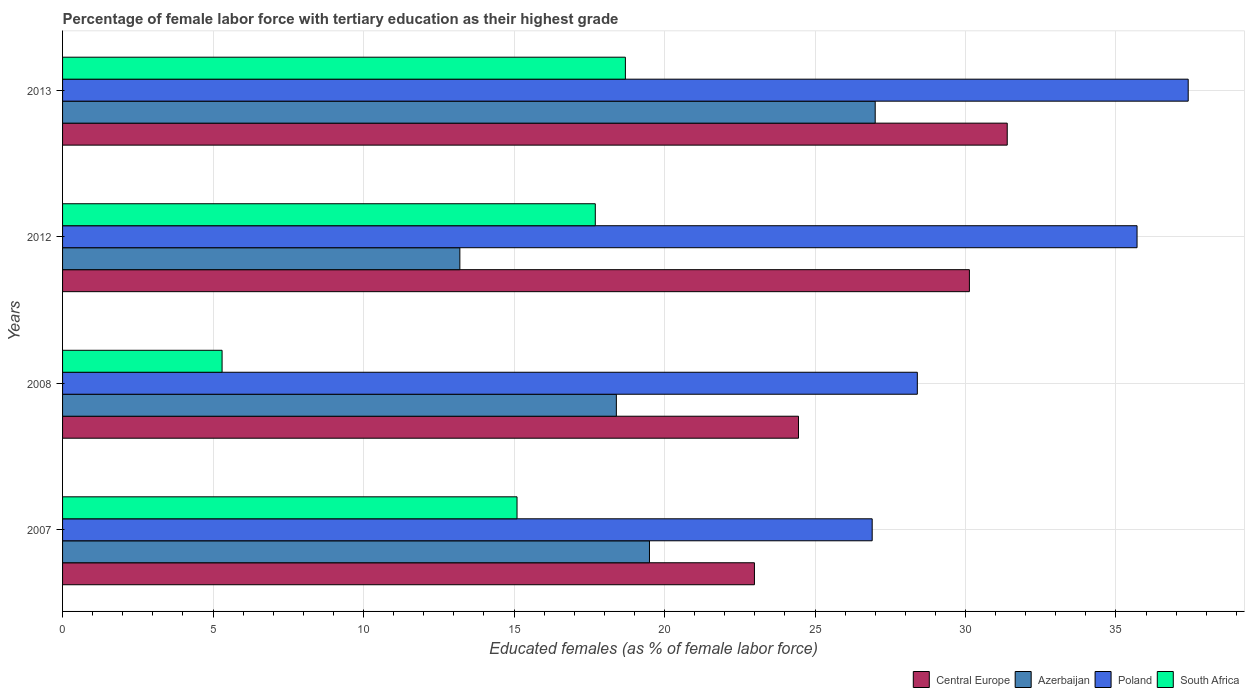How many different coloured bars are there?
Provide a succinct answer. 4. Are the number of bars per tick equal to the number of legend labels?
Provide a short and direct response. Yes. Are the number of bars on each tick of the Y-axis equal?
Offer a very short reply. Yes. How many bars are there on the 2nd tick from the top?
Provide a succinct answer. 4. What is the label of the 3rd group of bars from the top?
Keep it short and to the point. 2008. What is the percentage of female labor force with tertiary education in South Africa in 2008?
Provide a succinct answer. 5.3. Across all years, what is the maximum percentage of female labor force with tertiary education in South Africa?
Ensure brevity in your answer.  18.7. Across all years, what is the minimum percentage of female labor force with tertiary education in Poland?
Ensure brevity in your answer.  26.9. In which year was the percentage of female labor force with tertiary education in Central Europe minimum?
Provide a succinct answer. 2007. What is the total percentage of female labor force with tertiary education in Poland in the graph?
Keep it short and to the point. 128.4. What is the difference between the percentage of female labor force with tertiary education in South Africa in 2007 and that in 2008?
Offer a very short reply. 9.8. What is the difference between the percentage of female labor force with tertiary education in Azerbaijan in 2013 and the percentage of female labor force with tertiary education in Central Europe in 2007?
Provide a short and direct response. 4.01. What is the average percentage of female labor force with tertiary education in Azerbaijan per year?
Keep it short and to the point. 19.52. In the year 2007, what is the difference between the percentage of female labor force with tertiary education in South Africa and percentage of female labor force with tertiary education in Azerbaijan?
Your answer should be very brief. -4.4. In how many years, is the percentage of female labor force with tertiary education in South Africa greater than 13 %?
Your response must be concise. 3. What is the ratio of the percentage of female labor force with tertiary education in Azerbaijan in 2007 to that in 2013?
Provide a short and direct response. 0.72. Is the percentage of female labor force with tertiary education in Poland in 2007 less than that in 2008?
Your answer should be very brief. Yes. Is the difference between the percentage of female labor force with tertiary education in South Africa in 2007 and 2008 greater than the difference between the percentage of female labor force with tertiary education in Azerbaijan in 2007 and 2008?
Your response must be concise. Yes. What is the difference between the highest and the second highest percentage of female labor force with tertiary education in Azerbaijan?
Your answer should be very brief. 7.5. What is the difference between the highest and the lowest percentage of female labor force with tertiary education in Azerbaijan?
Ensure brevity in your answer.  13.8. In how many years, is the percentage of female labor force with tertiary education in South Africa greater than the average percentage of female labor force with tertiary education in South Africa taken over all years?
Your answer should be very brief. 3. Is it the case that in every year, the sum of the percentage of female labor force with tertiary education in Azerbaijan and percentage of female labor force with tertiary education in Central Europe is greater than the sum of percentage of female labor force with tertiary education in Poland and percentage of female labor force with tertiary education in South Africa?
Give a very brief answer. Yes. What does the 2nd bar from the bottom in 2012 represents?
Give a very brief answer. Azerbaijan. How many bars are there?
Provide a short and direct response. 16. How many years are there in the graph?
Offer a very short reply. 4. What is the difference between two consecutive major ticks on the X-axis?
Make the answer very short. 5. Are the values on the major ticks of X-axis written in scientific E-notation?
Provide a succinct answer. No. Does the graph contain any zero values?
Your answer should be compact. No. What is the title of the graph?
Offer a terse response. Percentage of female labor force with tertiary education as their highest grade. Does "Micronesia" appear as one of the legend labels in the graph?
Provide a succinct answer. No. What is the label or title of the X-axis?
Your answer should be very brief. Educated females (as % of female labor force). What is the Educated females (as % of female labor force) in Central Europe in 2007?
Ensure brevity in your answer.  22.99. What is the Educated females (as % of female labor force) in Azerbaijan in 2007?
Give a very brief answer. 19.5. What is the Educated females (as % of female labor force) in Poland in 2007?
Offer a terse response. 26.9. What is the Educated females (as % of female labor force) in South Africa in 2007?
Your answer should be compact. 15.1. What is the Educated females (as % of female labor force) in Central Europe in 2008?
Provide a short and direct response. 24.45. What is the Educated females (as % of female labor force) of Azerbaijan in 2008?
Make the answer very short. 18.4. What is the Educated females (as % of female labor force) in Poland in 2008?
Ensure brevity in your answer.  28.4. What is the Educated females (as % of female labor force) of South Africa in 2008?
Offer a very short reply. 5.3. What is the Educated females (as % of female labor force) in Central Europe in 2012?
Offer a very short reply. 30.13. What is the Educated females (as % of female labor force) of Azerbaijan in 2012?
Your answer should be very brief. 13.2. What is the Educated females (as % of female labor force) of Poland in 2012?
Offer a very short reply. 35.7. What is the Educated females (as % of female labor force) of South Africa in 2012?
Give a very brief answer. 17.7. What is the Educated females (as % of female labor force) in Central Europe in 2013?
Your answer should be compact. 31.39. What is the Educated females (as % of female labor force) in Poland in 2013?
Provide a short and direct response. 37.4. What is the Educated females (as % of female labor force) of South Africa in 2013?
Keep it short and to the point. 18.7. Across all years, what is the maximum Educated females (as % of female labor force) in Central Europe?
Offer a very short reply. 31.39. Across all years, what is the maximum Educated females (as % of female labor force) in Azerbaijan?
Keep it short and to the point. 27. Across all years, what is the maximum Educated females (as % of female labor force) in Poland?
Provide a succinct answer. 37.4. Across all years, what is the maximum Educated females (as % of female labor force) of South Africa?
Provide a succinct answer. 18.7. Across all years, what is the minimum Educated females (as % of female labor force) of Central Europe?
Keep it short and to the point. 22.99. Across all years, what is the minimum Educated females (as % of female labor force) in Azerbaijan?
Your response must be concise. 13.2. Across all years, what is the minimum Educated females (as % of female labor force) of Poland?
Your answer should be compact. 26.9. Across all years, what is the minimum Educated females (as % of female labor force) of South Africa?
Your answer should be compact. 5.3. What is the total Educated females (as % of female labor force) of Central Europe in the graph?
Offer a very short reply. 108.96. What is the total Educated females (as % of female labor force) of Azerbaijan in the graph?
Your response must be concise. 78.1. What is the total Educated females (as % of female labor force) in Poland in the graph?
Offer a terse response. 128.4. What is the total Educated females (as % of female labor force) in South Africa in the graph?
Offer a very short reply. 56.8. What is the difference between the Educated females (as % of female labor force) in Central Europe in 2007 and that in 2008?
Provide a succinct answer. -1.46. What is the difference between the Educated females (as % of female labor force) of Poland in 2007 and that in 2008?
Keep it short and to the point. -1.5. What is the difference between the Educated females (as % of female labor force) in South Africa in 2007 and that in 2008?
Offer a terse response. 9.8. What is the difference between the Educated females (as % of female labor force) in Central Europe in 2007 and that in 2012?
Make the answer very short. -7.14. What is the difference between the Educated females (as % of female labor force) of Azerbaijan in 2007 and that in 2012?
Provide a succinct answer. 6.3. What is the difference between the Educated females (as % of female labor force) in Central Europe in 2007 and that in 2013?
Give a very brief answer. -8.4. What is the difference between the Educated females (as % of female labor force) of Azerbaijan in 2007 and that in 2013?
Give a very brief answer. -7.5. What is the difference between the Educated females (as % of female labor force) in Poland in 2007 and that in 2013?
Your response must be concise. -10.5. What is the difference between the Educated females (as % of female labor force) in South Africa in 2007 and that in 2013?
Make the answer very short. -3.6. What is the difference between the Educated females (as % of female labor force) in Central Europe in 2008 and that in 2012?
Provide a short and direct response. -5.68. What is the difference between the Educated females (as % of female labor force) of Azerbaijan in 2008 and that in 2012?
Make the answer very short. 5.2. What is the difference between the Educated females (as % of female labor force) of Poland in 2008 and that in 2012?
Ensure brevity in your answer.  -7.3. What is the difference between the Educated females (as % of female labor force) of Central Europe in 2008 and that in 2013?
Your answer should be compact. -6.94. What is the difference between the Educated females (as % of female labor force) of Azerbaijan in 2008 and that in 2013?
Give a very brief answer. -8.6. What is the difference between the Educated females (as % of female labor force) in South Africa in 2008 and that in 2013?
Your answer should be compact. -13.4. What is the difference between the Educated females (as % of female labor force) of Central Europe in 2012 and that in 2013?
Give a very brief answer. -1.26. What is the difference between the Educated females (as % of female labor force) of Poland in 2012 and that in 2013?
Give a very brief answer. -1.7. What is the difference between the Educated females (as % of female labor force) of Central Europe in 2007 and the Educated females (as % of female labor force) of Azerbaijan in 2008?
Your answer should be very brief. 4.59. What is the difference between the Educated females (as % of female labor force) in Central Europe in 2007 and the Educated females (as % of female labor force) in Poland in 2008?
Offer a terse response. -5.41. What is the difference between the Educated females (as % of female labor force) in Central Europe in 2007 and the Educated females (as % of female labor force) in South Africa in 2008?
Offer a very short reply. 17.69. What is the difference between the Educated females (as % of female labor force) of Poland in 2007 and the Educated females (as % of female labor force) of South Africa in 2008?
Give a very brief answer. 21.6. What is the difference between the Educated females (as % of female labor force) of Central Europe in 2007 and the Educated females (as % of female labor force) of Azerbaijan in 2012?
Make the answer very short. 9.79. What is the difference between the Educated females (as % of female labor force) in Central Europe in 2007 and the Educated females (as % of female labor force) in Poland in 2012?
Provide a succinct answer. -12.71. What is the difference between the Educated females (as % of female labor force) in Central Europe in 2007 and the Educated females (as % of female labor force) in South Africa in 2012?
Offer a terse response. 5.29. What is the difference between the Educated females (as % of female labor force) of Azerbaijan in 2007 and the Educated females (as % of female labor force) of Poland in 2012?
Your answer should be compact. -16.2. What is the difference between the Educated females (as % of female labor force) of Azerbaijan in 2007 and the Educated females (as % of female labor force) of South Africa in 2012?
Offer a very short reply. 1.8. What is the difference between the Educated females (as % of female labor force) in Central Europe in 2007 and the Educated females (as % of female labor force) in Azerbaijan in 2013?
Provide a succinct answer. -4.01. What is the difference between the Educated females (as % of female labor force) in Central Europe in 2007 and the Educated females (as % of female labor force) in Poland in 2013?
Make the answer very short. -14.41. What is the difference between the Educated females (as % of female labor force) in Central Europe in 2007 and the Educated females (as % of female labor force) in South Africa in 2013?
Keep it short and to the point. 4.29. What is the difference between the Educated females (as % of female labor force) of Azerbaijan in 2007 and the Educated females (as % of female labor force) of Poland in 2013?
Keep it short and to the point. -17.9. What is the difference between the Educated females (as % of female labor force) of Azerbaijan in 2007 and the Educated females (as % of female labor force) of South Africa in 2013?
Provide a succinct answer. 0.8. What is the difference between the Educated females (as % of female labor force) of Central Europe in 2008 and the Educated females (as % of female labor force) of Azerbaijan in 2012?
Offer a terse response. 11.25. What is the difference between the Educated females (as % of female labor force) of Central Europe in 2008 and the Educated females (as % of female labor force) of Poland in 2012?
Give a very brief answer. -11.25. What is the difference between the Educated females (as % of female labor force) in Central Europe in 2008 and the Educated females (as % of female labor force) in South Africa in 2012?
Ensure brevity in your answer.  6.75. What is the difference between the Educated females (as % of female labor force) in Azerbaijan in 2008 and the Educated females (as % of female labor force) in Poland in 2012?
Make the answer very short. -17.3. What is the difference between the Educated females (as % of female labor force) in Azerbaijan in 2008 and the Educated females (as % of female labor force) in South Africa in 2012?
Provide a succinct answer. 0.7. What is the difference between the Educated females (as % of female labor force) of Poland in 2008 and the Educated females (as % of female labor force) of South Africa in 2012?
Offer a very short reply. 10.7. What is the difference between the Educated females (as % of female labor force) of Central Europe in 2008 and the Educated females (as % of female labor force) of Azerbaijan in 2013?
Offer a terse response. -2.55. What is the difference between the Educated females (as % of female labor force) in Central Europe in 2008 and the Educated females (as % of female labor force) in Poland in 2013?
Your answer should be very brief. -12.95. What is the difference between the Educated females (as % of female labor force) of Central Europe in 2008 and the Educated females (as % of female labor force) of South Africa in 2013?
Provide a short and direct response. 5.75. What is the difference between the Educated females (as % of female labor force) of Poland in 2008 and the Educated females (as % of female labor force) of South Africa in 2013?
Give a very brief answer. 9.7. What is the difference between the Educated females (as % of female labor force) of Central Europe in 2012 and the Educated females (as % of female labor force) of Azerbaijan in 2013?
Provide a succinct answer. 3.13. What is the difference between the Educated females (as % of female labor force) in Central Europe in 2012 and the Educated females (as % of female labor force) in Poland in 2013?
Give a very brief answer. -7.27. What is the difference between the Educated females (as % of female labor force) in Central Europe in 2012 and the Educated females (as % of female labor force) in South Africa in 2013?
Ensure brevity in your answer.  11.43. What is the difference between the Educated females (as % of female labor force) in Azerbaijan in 2012 and the Educated females (as % of female labor force) in Poland in 2013?
Your answer should be compact. -24.2. What is the average Educated females (as % of female labor force) of Central Europe per year?
Your answer should be compact. 27.24. What is the average Educated females (as % of female labor force) of Azerbaijan per year?
Keep it short and to the point. 19.52. What is the average Educated females (as % of female labor force) in Poland per year?
Provide a short and direct response. 32.1. In the year 2007, what is the difference between the Educated females (as % of female labor force) of Central Europe and Educated females (as % of female labor force) of Azerbaijan?
Make the answer very short. 3.49. In the year 2007, what is the difference between the Educated females (as % of female labor force) of Central Europe and Educated females (as % of female labor force) of Poland?
Keep it short and to the point. -3.91. In the year 2007, what is the difference between the Educated females (as % of female labor force) of Central Europe and Educated females (as % of female labor force) of South Africa?
Provide a short and direct response. 7.89. In the year 2007, what is the difference between the Educated females (as % of female labor force) of Azerbaijan and Educated females (as % of female labor force) of Poland?
Keep it short and to the point. -7.4. In the year 2007, what is the difference between the Educated females (as % of female labor force) in Poland and Educated females (as % of female labor force) in South Africa?
Your answer should be very brief. 11.8. In the year 2008, what is the difference between the Educated females (as % of female labor force) in Central Europe and Educated females (as % of female labor force) in Azerbaijan?
Ensure brevity in your answer.  6.05. In the year 2008, what is the difference between the Educated females (as % of female labor force) in Central Europe and Educated females (as % of female labor force) in Poland?
Provide a succinct answer. -3.95. In the year 2008, what is the difference between the Educated females (as % of female labor force) of Central Europe and Educated females (as % of female labor force) of South Africa?
Provide a short and direct response. 19.15. In the year 2008, what is the difference between the Educated females (as % of female labor force) of Poland and Educated females (as % of female labor force) of South Africa?
Ensure brevity in your answer.  23.1. In the year 2012, what is the difference between the Educated females (as % of female labor force) in Central Europe and Educated females (as % of female labor force) in Azerbaijan?
Your answer should be compact. 16.93. In the year 2012, what is the difference between the Educated females (as % of female labor force) of Central Europe and Educated females (as % of female labor force) of Poland?
Give a very brief answer. -5.57. In the year 2012, what is the difference between the Educated females (as % of female labor force) of Central Europe and Educated females (as % of female labor force) of South Africa?
Your response must be concise. 12.43. In the year 2012, what is the difference between the Educated females (as % of female labor force) in Azerbaijan and Educated females (as % of female labor force) in Poland?
Your answer should be compact. -22.5. In the year 2012, what is the difference between the Educated females (as % of female labor force) of Poland and Educated females (as % of female labor force) of South Africa?
Offer a very short reply. 18. In the year 2013, what is the difference between the Educated females (as % of female labor force) of Central Europe and Educated females (as % of female labor force) of Azerbaijan?
Offer a terse response. 4.39. In the year 2013, what is the difference between the Educated females (as % of female labor force) in Central Europe and Educated females (as % of female labor force) in Poland?
Make the answer very short. -6.01. In the year 2013, what is the difference between the Educated females (as % of female labor force) in Central Europe and Educated females (as % of female labor force) in South Africa?
Ensure brevity in your answer.  12.69. In the year 2013, what is the difference between the Educated females (as % of female labor force) of Azerbaijan and Educated females (as % of female labor force) of Poland?
Provide a short and direct response. -10.4. In the year 2013, what is the difference between the Educated females (as % of female labor force) in Poland and Educated females (as % of female labor force) in South Africa?
Your answer should be compact. 18.7. What is the ratio of the Educated females (as % of female labor force) of Central Europe in 2007 to that in 2008?
Keep it short and to the point. 0.94. What is the ratio of the Educated females (as % of female labor force) in Azerbaijan in 2007 to that in 2008?
Your answer should be compact. 1.06. What is the ratio of the Educated females (as % of female labor force) of Poland in 2007 to that in 2008?
Offer a very short reply. 0.95. What is the ratio of the Educated females (as % of female labor force) in South Africa in 2007 to that in 2008?
Provide a succinct answer. 2.85. What is the ratio of the Educated females (as % of female labor force) of Central Europe in 2007 to that in 2012?
Your response must be concise. 0.76. What is the ratio of the Educated females (as % of female labor force) of Azerbaijan in 2007 to that in 2012?
Ensure brevity in your answer.  1.48. What is the ratio of the Educated females (as % of female labor force) in Poland in 2007 to that in 2012?
Keep it short and to the point. 0.75. What is the ratio of the Educated females (as % of female labor force) in South Africa in 2007 to that in 2012?
Keep it short and to the point. 0.85. What is the ratio of the Educated females (as % of female labor force) in Central Europe in 2007 to that in 2013?
Offer a terse response. 0.73. What is the ratio of the Educated females (as % of female labor force) of Azerbaijan in 2007 to that in 2013?
Ensure brevity in your answer.  0.72. What is the ratio of the Educated females (as % of female labor force) of Poland in 2007 to that in 2013?
Make the answer very short. 0.72. What is the ratio of the Educated females (as % of female labor force) in South Africa in 2007 to that in 2013?
Offer a terse response. 0.81. What is the ratio of the Educated females (as % of female labor force) of Central Europe in 2008 to that in 2012?
Your answer should be compact. 0.81. What is the ratio of the Educated females (as % of female labor force) in Azerbaijan in 2008 to that in 2012?
Your response must be concise. 1.39. What is the ratio of the Educated females (as % of female labor force) in Poland in 2008 to that in 2012?
Ensure brevity in your answer.  0.8. What is the ratio of the Educated females (as % of female labor force) of South Africa in 2008 to that in 2012?
Ensure brevity in your answer.  0.3. What is the ratio of the Educated females (as % of female labor force) of Central Europe in 2008 to that in 2013?
Make the answer very short. 0.78. What is the ratio of the Educated females (as % of female labor force) of Azerbaijan in 2008 to that in 2013?
Your answer should be compact. 0.68. What is the ratio of the Educated females (as % of female labor force) in Poland in 2008 to that in 2013?
Provide a short and direct response. 0.76. What is the ratio of the Educated females (as % of female labor force) of South Africa in 2008 to that in 2013?
Give a very brief answer. 0.28. What is the ratio of the Educated females (as % of female labor force) in Azerbaijan in 2012 to that in 2013?
Ensure brevity in your answer.  0.49. What is the ratio of the Educated females (as % of female labor force) in Poland in 2012 to that in 2013?
Provide a short and direct response. 0.95. What is the ratio of the Educated females (as % of female labor force) of South Africa in 2012 to that in 2013?
Offer a terse response. 0.95. What is the difference between the highest and the second highest Educated females (as % of female labor force) in Central Europe?
Make the answer very short. 1.26. What is the difference between the highest and the second highest Educated females (as % of female labor force) of Azerbaijan?
Ensure brevity in your answer.  7.5. What is the difference between the highest and the second highest Educated females (as % of female labor force) in Poland?
Make the answer very short. 1.7. What is the difference between the highest and the lowest Educated females (as % of female labor force) in Central Europe?
Your answer should be very brief. 8.4. What is the difference between the highest and the lowest Educated females (as % of female labor force) of Azerbaijan?
Make the answer very short. 13.8. What is the difference between the highest and the lowest Educated females (as % of female labor force) of Poland?
Make the answer very short. 10.5. What is the difference between the highest and the lowest Educated females (as % of female labor force) of South Africa?
Make the answer very short. 13.4. 